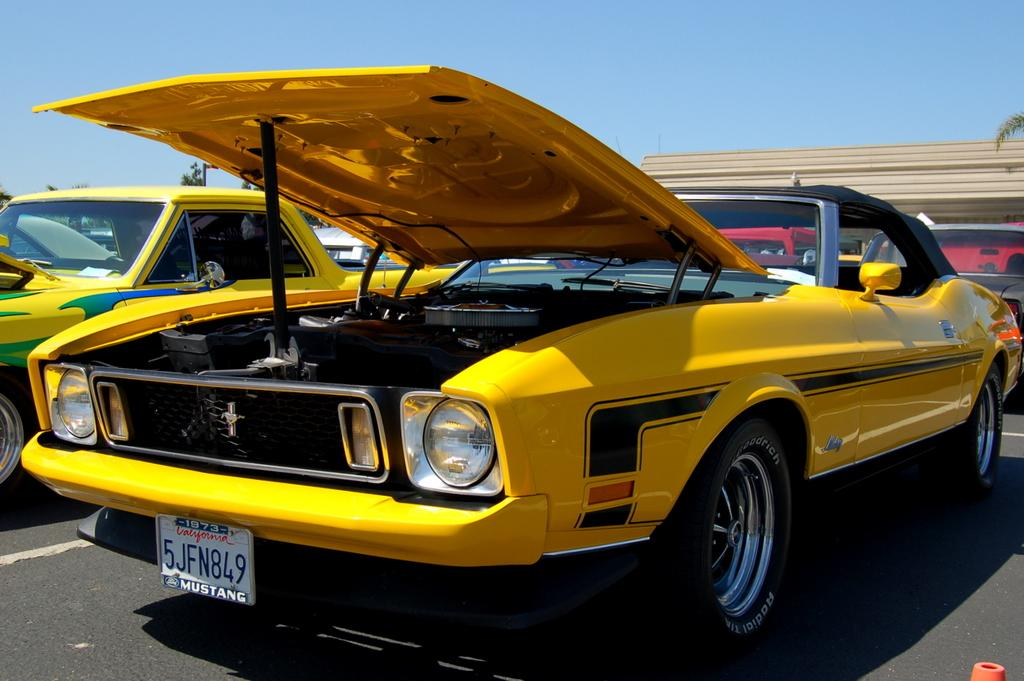What is located at the bottom of the image? There is a road at the bottom of the image. What can be seen traveling on the road? There are vehicles in the image. What type of natural vegetation is present in the image? There are trees in the image. What is visible at the top of the image? The sky is visible at the top of the image. What type of bell can be heard ringing in the image? There is no bell present in the image, and therefore no sound can be heard. 